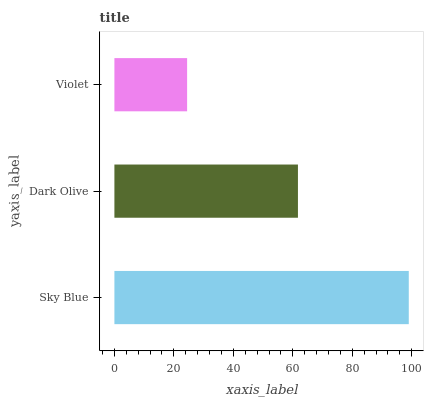Is Violet the minimum?
Answer yes or no. Yes. Is Sky Blue the maximum?
Answer yes or no. Yes. Is Dark Olive the minimum?
Answer yes or no. No. Is Dark Olive the maximum?
Answer yes or no. No. Is Sky Blue greater than Dark Olive?
Answer yes or no. Yes. Is Dark Olive less than Sky Blue?
Answer yes or no. Yes. Is Dark Olive greater than Sky Blue?
Answer yes or no. No. Is Sky Blue less than Dark Olive?
Answer yes or no. No. Is Dark Olive the high median?
Answer yes or no. Yes. Is Dark Olive the low median?
Answer yes or no. Yes. Is Violet the high median?
Answer yes or no. No. Is Sky Blue the low median?
Answer yes or no. No. 